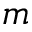<formula> <loc_0><loc_0><loc_500><loc_500>m</formula> 